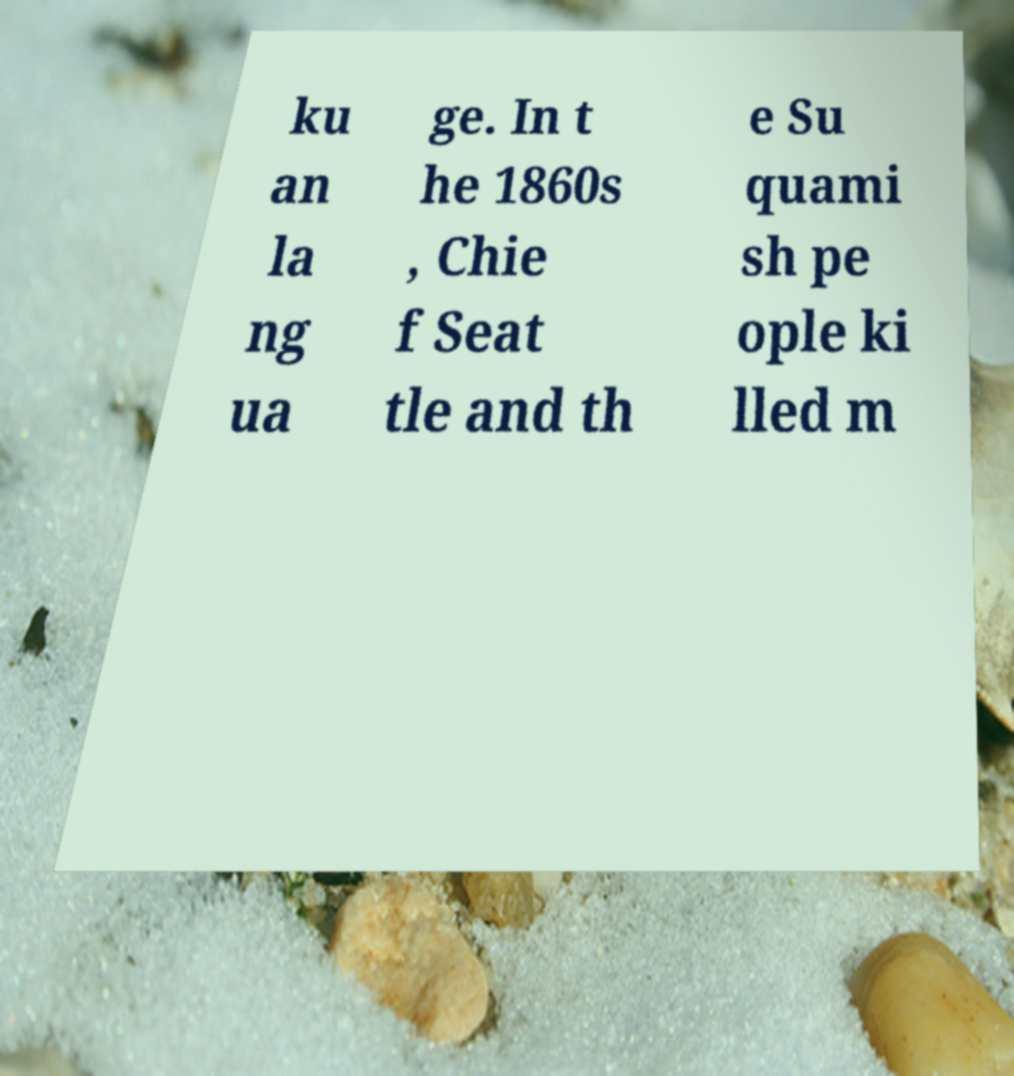I need the written content from this picture converted into text. Can you do that? ku an la ng ua ge. In t he 1860s , Chie f Seat tle and th e Su quami sh pe ople ki lled m 